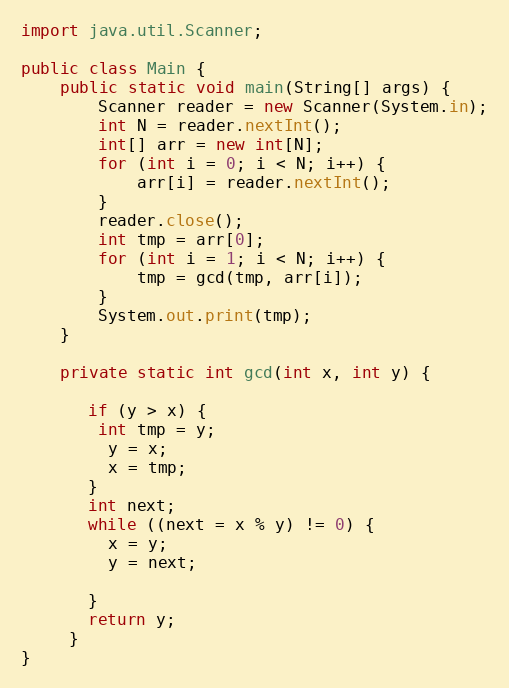Convert code to text. <code><loc_0><loc_0><loc_500><loc_500><_Java_>
import java.util.Scanner;

public class Main {
	public static void main(String[] args) {
		Scanner reader = new Scanner(System.in);
		int N = reader.nextInt();
		int[] arr = new int[N];
		for (int i = 0; i < N; i++) {
			arr[i] = reader.nextInt();
		}
		reader.close();
		int tmp = arr[0];
		for (int i = 1; i < N; i++) {
			tmp = gcd(tmp, arr[i]);
		}
		System.out.print(tmp);
	}

	private static int gcd(int x, int y) {

	   if (y > x) {
	   	int tmp = y;
	     y = x;
	     x = tmp;
	   }
	   int next;
	   while ((next = x % y) != 0) {
	     x = y;
	     y = next;

	   }
	   return y;
	 }
}

</code> 